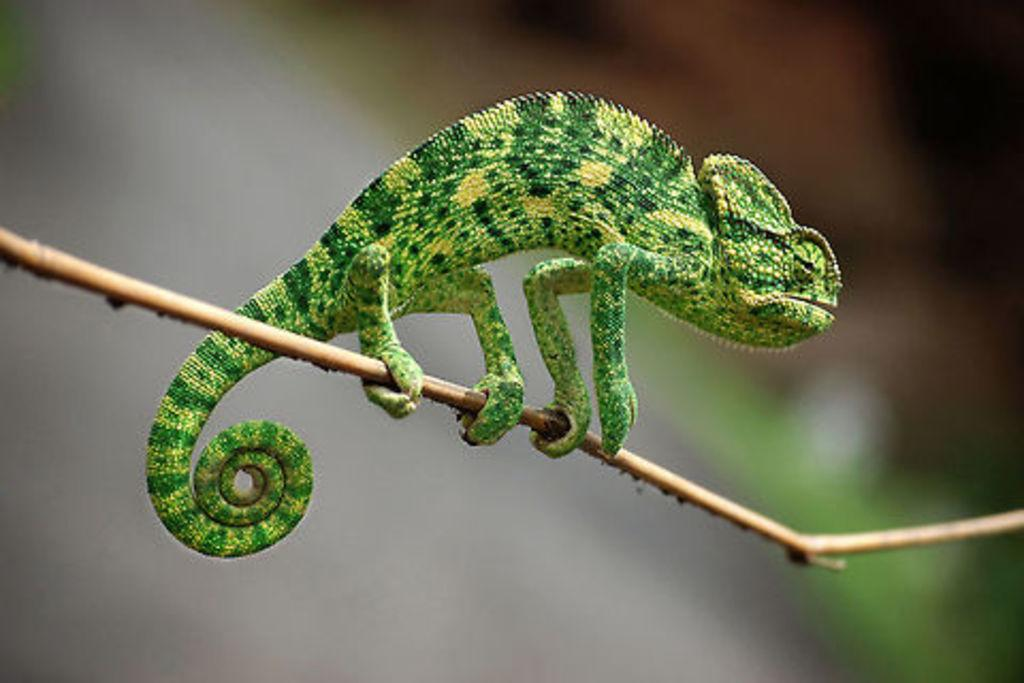What type of animal is in the image? There is a chameleon in the image. What is the chameleon resting on? The chameleon is on a stick. Can you describe the background of the image? The background of the image is blurred. What type of insurance policy is the chameleon promoting in the image? There is no mention of insurance or any promotional material in the image; it simply features a chameleon on a stick with a blurred background. 